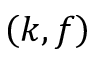<formula> <loc_0><loc_0><loc_500><loc_500>\left ( k , f \right )</formula> 